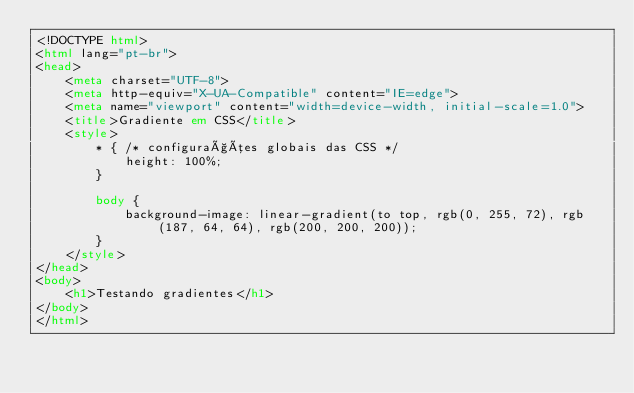Convert code to text. <code><loc_0><loc_0><loc_500><loc_500><_HTML_><!DOCTYPE html>
<html lang="pt-br">
<head>
    <meta charset="UTF-8">
    <meta http-equiv="X-UA-Compatible" content="IE=edge">
    <meta name="viewport" content="width=device-width, initial-scale=1.0">
    <title>Gradiente em CSS</title>
    <style>
        * { /* configurações globais das CSS */
            height: 100%;
        }

        body {
            background-image: linear-gradient(to top, rgb(0, 255, 72), rgb(187, 64, 64), rgb(200, 200, 200));
        }
    </style>
</head>
<body>
    <h1>Testando gradientes</h1>
</body>
</html></code> 